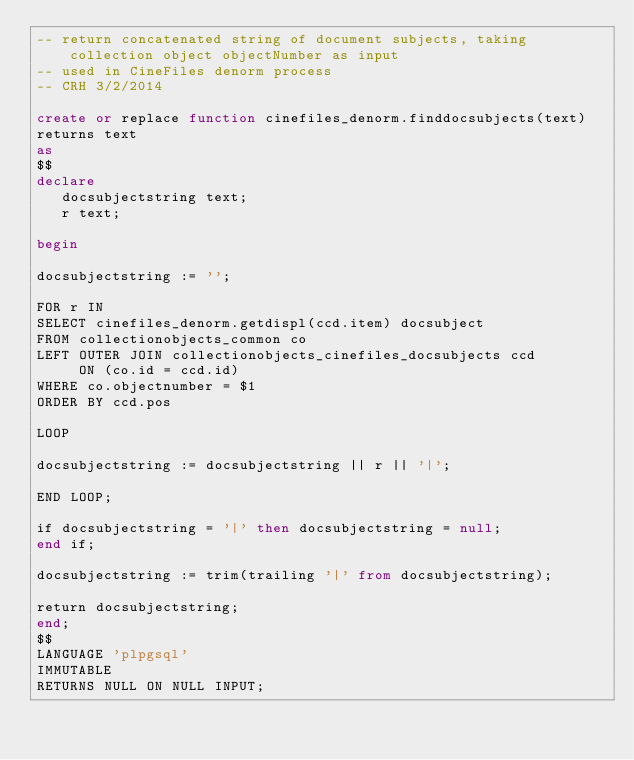Convert code to text. <code><loc_0><loc_0><loc_500><loc_500><_SQL_>-- return concatenated string of document subjects, taking collection object objectNumber as input
-- used in CineFiles denorm process
-- CRH 3/2/2014

create or replace function cinefiles_denorm.finddocsubjects(text)
returns text
as
$$
declare
   docsubjectstring text;
   r text;

begin

docsubjectstring := '';

FOR r IN
SELECT cinefiles_denorm.getdispl(ccd.item) docsubject
FROM collectionobjects_common co
LEFT OUTER JOIN collectionobjects_cinefiles_docsubjects ccd
     ON (co.id = ccd.id)
WHERE co.objectnumber = $1
ORDER BY ccd.pos

LOOP

docsubjectstring := docsubjectstring || r || '|';

END LOOP;

if docsubjectstring = '|' then docsubjectstring = null;
end if;

docsubjectstring := trim(trailing '|' from docsubjectstring);

return docsubjectstring;
end;
$$
LANGUAGE 'plpgsql'
IMMUTABLE
RETURNS NULL ON NULL INPUT;</code> 